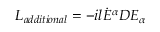<formula> <loc_0><loc_0><loc_500><loc_500>L _ { a d d i t i o n a l } = - i l { \dot { E } } ^ { \alpha } D E _ { \alpha }</formula> 